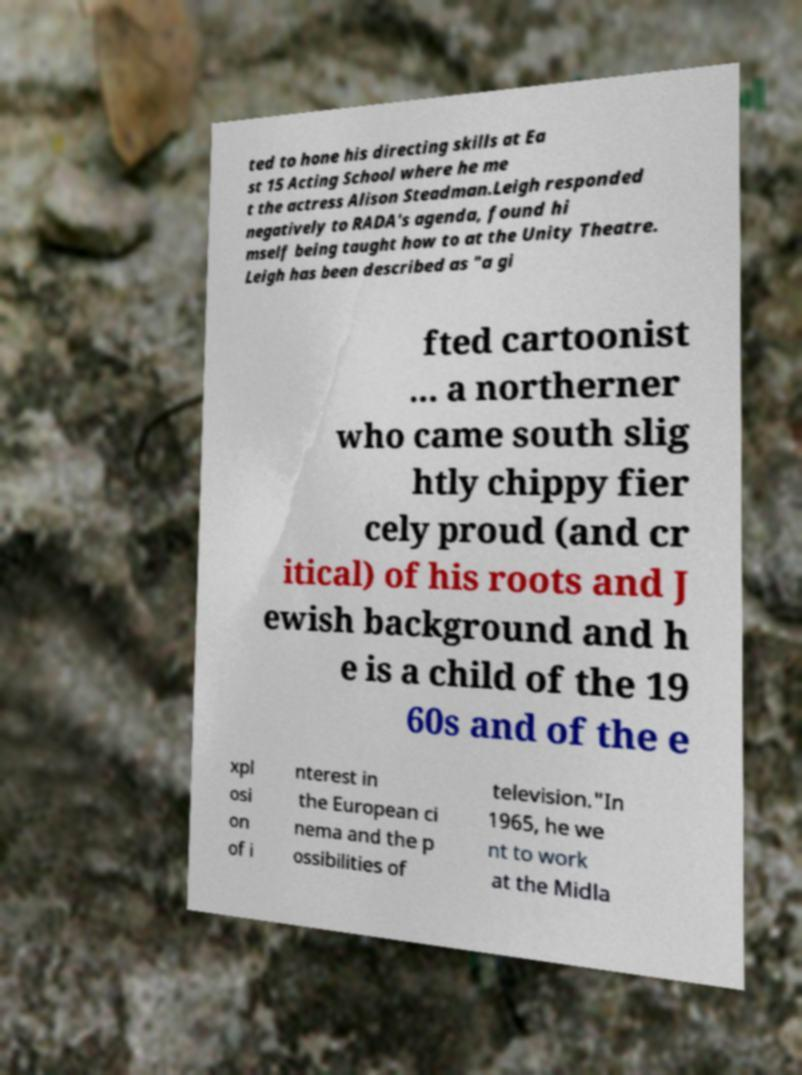Could you assist in decoding the text presented in this image and type it out clearly? ted to hone his directing skills at Ea st 15 Acting School where he me t the actress Alison Steadman.Leigh responded negatively to RADA's agenda, found hi mself being taught how to at the Unity Theatre. Leigh has been described as "a gi fted cartoonist ... a northerner who came south slig htly chippy fier cely proud (and cr itical) of his roots and J ewish background and h e is a child of the 19 60s and of the e xpl osi on of i nterest in the European ci nema and the p ossibilities of television."In 1965, he we nt to work at the Midla 